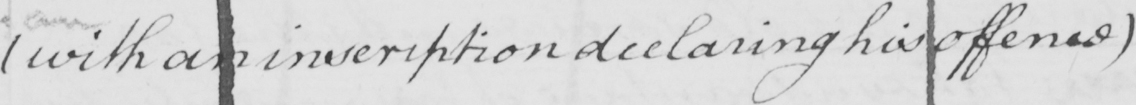Transcribe the text shown in this historical manuscript line. ( with an inscription declaring his offence ) 